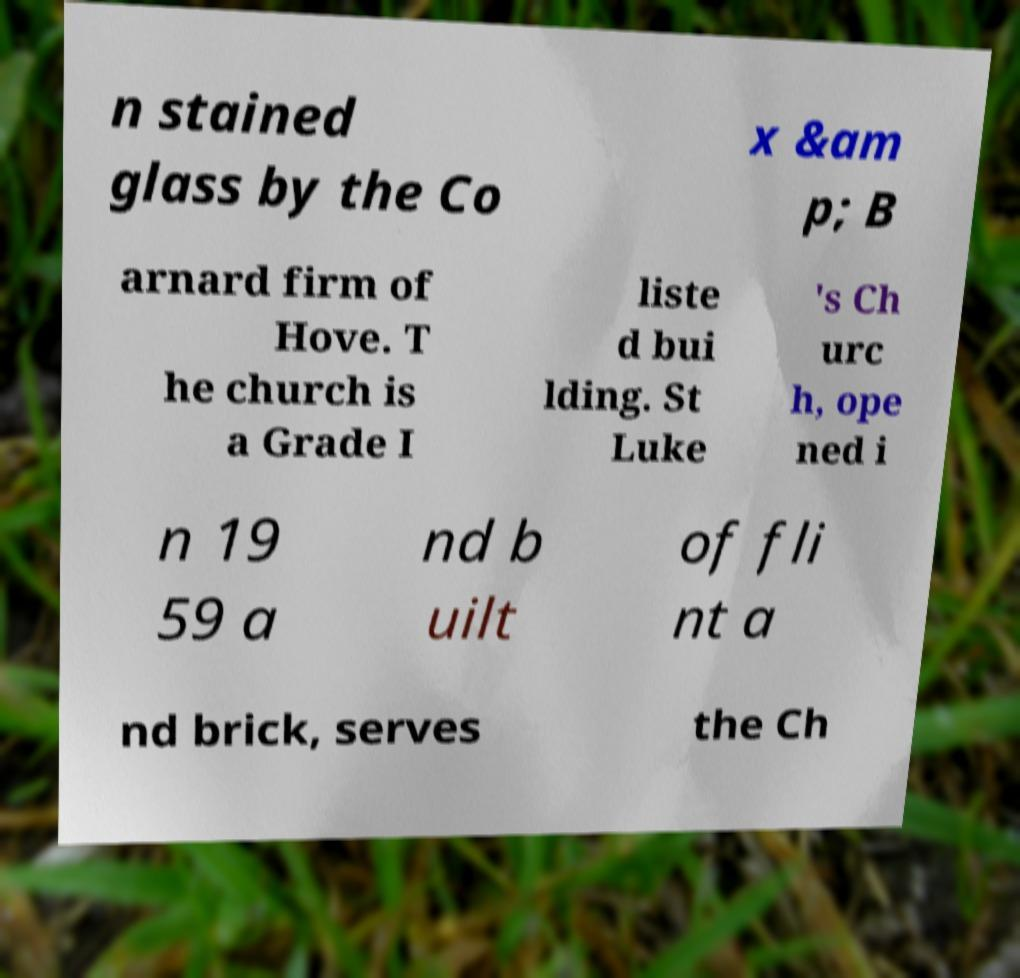Please identify and transcribe the text found in this image. n stained glass by the Co x &am p; B arnard firm of Hove. T he church is a Grade I liste d bui lding. St Luke 's Ch urc h, ope ned i n 19 59 a nd b uilt of fli nt a nd brick, serves the Ch 